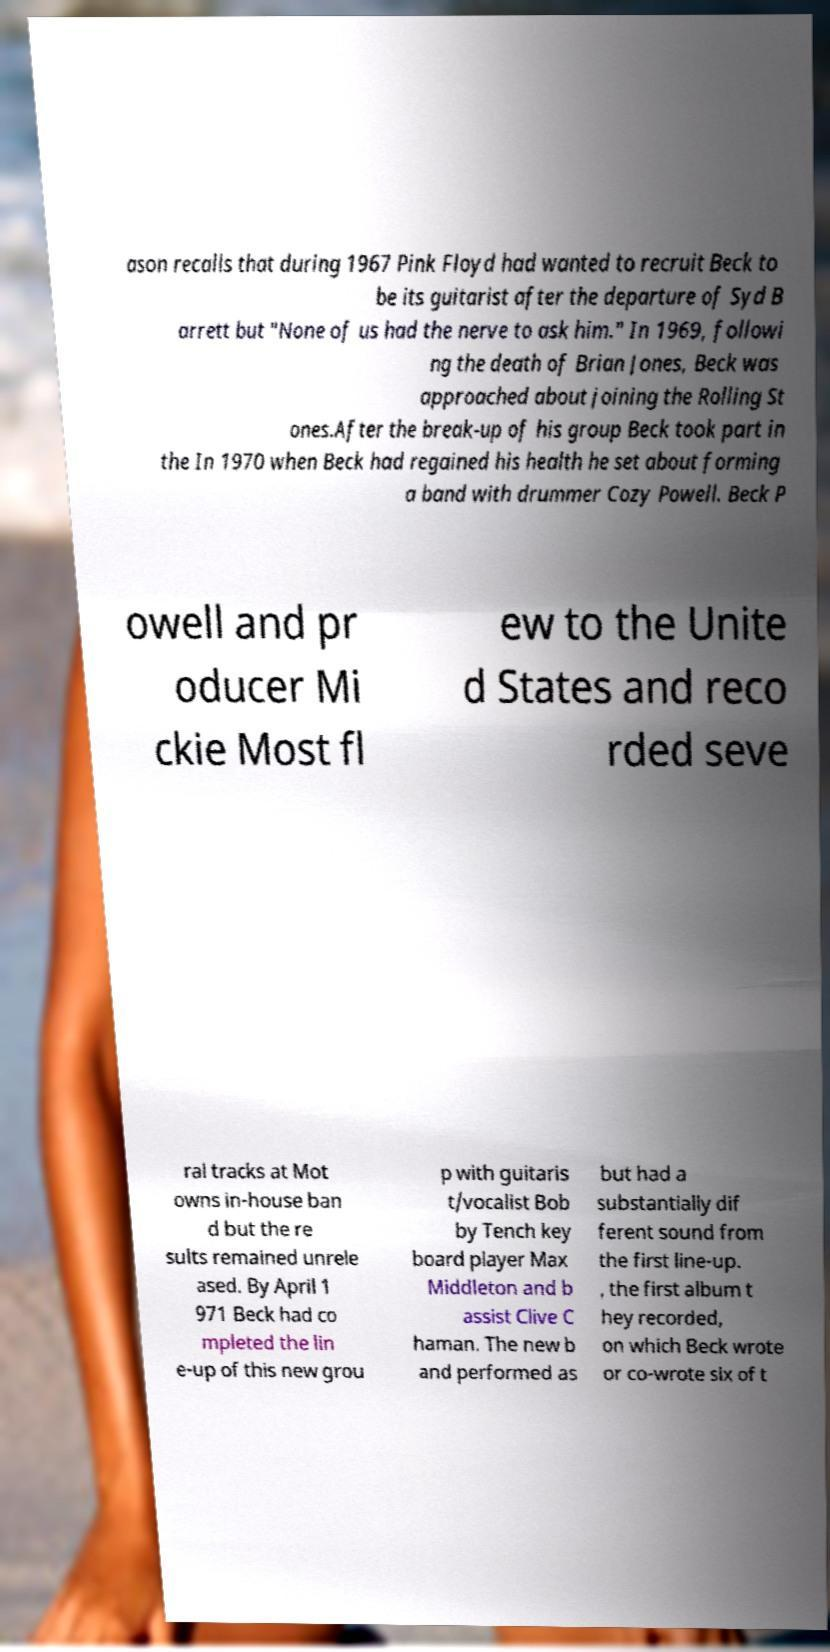Can you read and provide the text displayed in the image?This photo seems to have some interesting text. Can you extract and type it out for me? ason recalls that during 1967 Pink Floyd had wanted to recruit Beck to be its guitarist after the departure of Syd B arrett but "None of us had the nerve to ask him." In 1969, followi ng the death of Brian Jones, Beck was approached about joining the Rolling St ones.After the break-up of his group Beck took part in the In 1970 when Beck had regained his health he set about forming a band with drummer Cozy Powell. Beck P owell and pr oducer Mi ckie Most fl ew to the Unite d States and reco rded seve ral tracks at Mot owns in-house ban d but the re sults remained unrele ased. By April 1 971 Beck had co mpleted the lin e-up of this new grou p with guitaris t/vocalist Bob by Tench key board player Max Middleton and b assist Clive C haman. The new b and performed as but had a substantially dif ferent sound from the first line-up. , the first album t hey recorded, on which Beck wrote or co-wrote six of t 